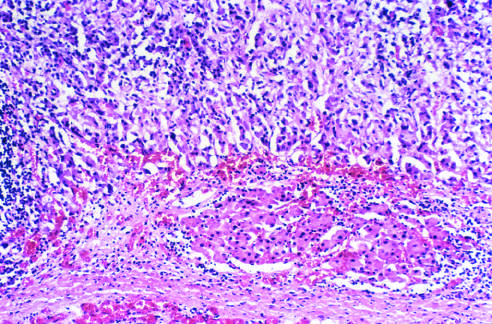what does the tumor compress?
Answer the question using a single word or phrase. The upper pole 